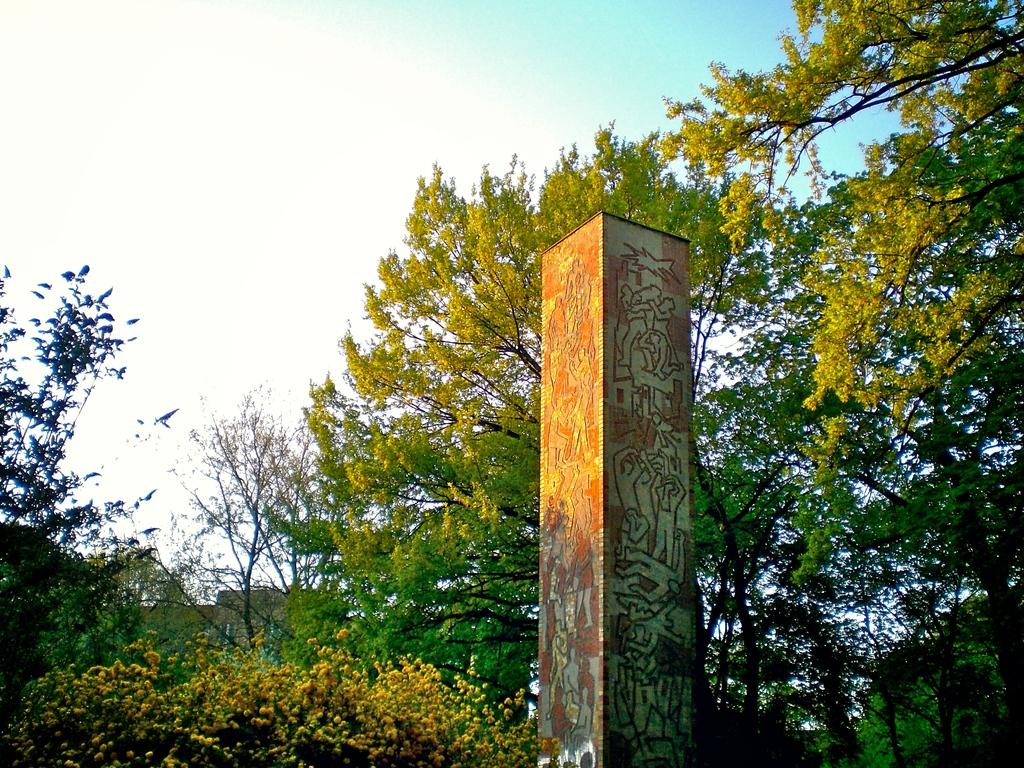What is the main structure in the middle of the image? There is a pillar in the middle of the image. What can be seen in the background of the image? There are trees in the background of the image. What is visible at the top of the image? The sky is visible at the top of the image. What type of leaf is being used as a desk in the image? There is no leaf or desk present in the image. 